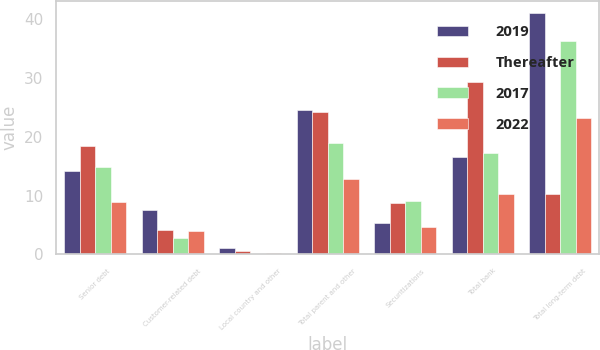Convert chart. <chart><loc_0><loc_0><loc_500><loc_500><stacked_bar_chart><ecel><fcel>Senior debt<fcel>Customer-related debt<fcel>Local country and other<fcel>Total parent and other<fcel>Securitizations<fcel>Total bank<fcel>Total long-term debt<nl><fcel>2019<fcel>14.1<fcel>7.6<fcel>1.1<fcel>24.5<fcel>5.3<fcel>16.5<fcel>41<nl><fcel>Thereafter<fcel>18.4<fcel>4.2<fcel>0.6<fcel>24.2<fcel>8.7<fcel>29.3<fcel>10.3<nl><fcel>2017<fcel>14.8<fcel>2.8<fcel>0.1<fcel>19<fcel>9<fcel>17.2<fcel>36.3<nl><fcel>2022<fcel>8.9<fcel>3.9<fcel>0.2<fcel>12.9<fcel>4.6<fcel>10.3<fcel>23.2<nl></chart> 